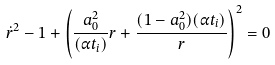Convert formula to latex. <formula><loc_0><loc_0><loc_500><loc_500>\dot { r } ^ { 2 } - 1 + \left ( \frac { a _ { 0 } ^ { 2 } } { ( \alpha t _ { i } ) } r + \frac { ( 1 - a _ { 0 } ^ { 2 } ) ( \alpha t _ { i } ) } { r } \right ) ^ { 2 } = 0</formula> 